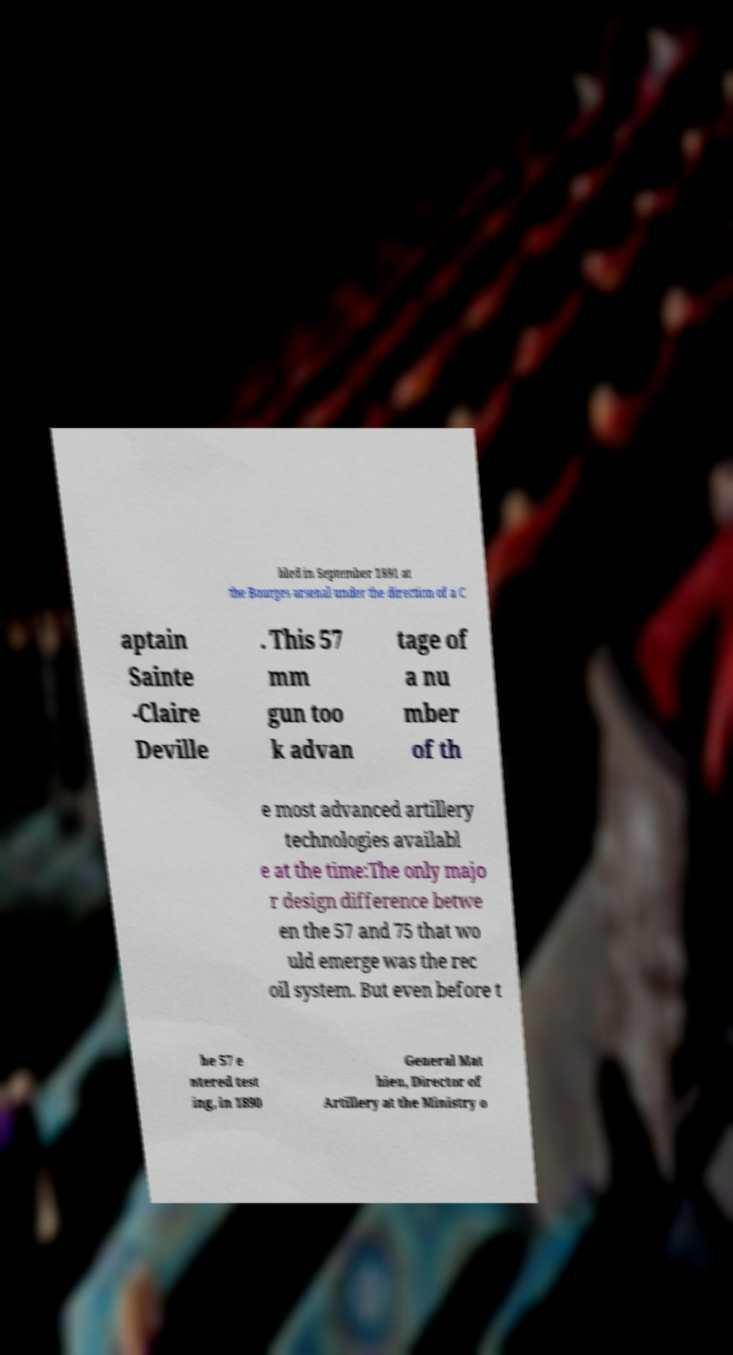There's text embedded in this image that I need extracted. Can you transcribe it verbatim? bled in September 1891 at the Bourges arsenal under the direction of a C aptain Sainte -Claire Deville . This 57 mm gun too k advan tage of a nu mber of th e most advanced artillery technologies availabl e at the time:The only majo r design difference betwe en the 57 and 75 that wo uld emerge was the rec oil system. But even before t he 57 e ntered test ing, in 1890 General Mat hieu, Director of Artillery at the Ministry o 